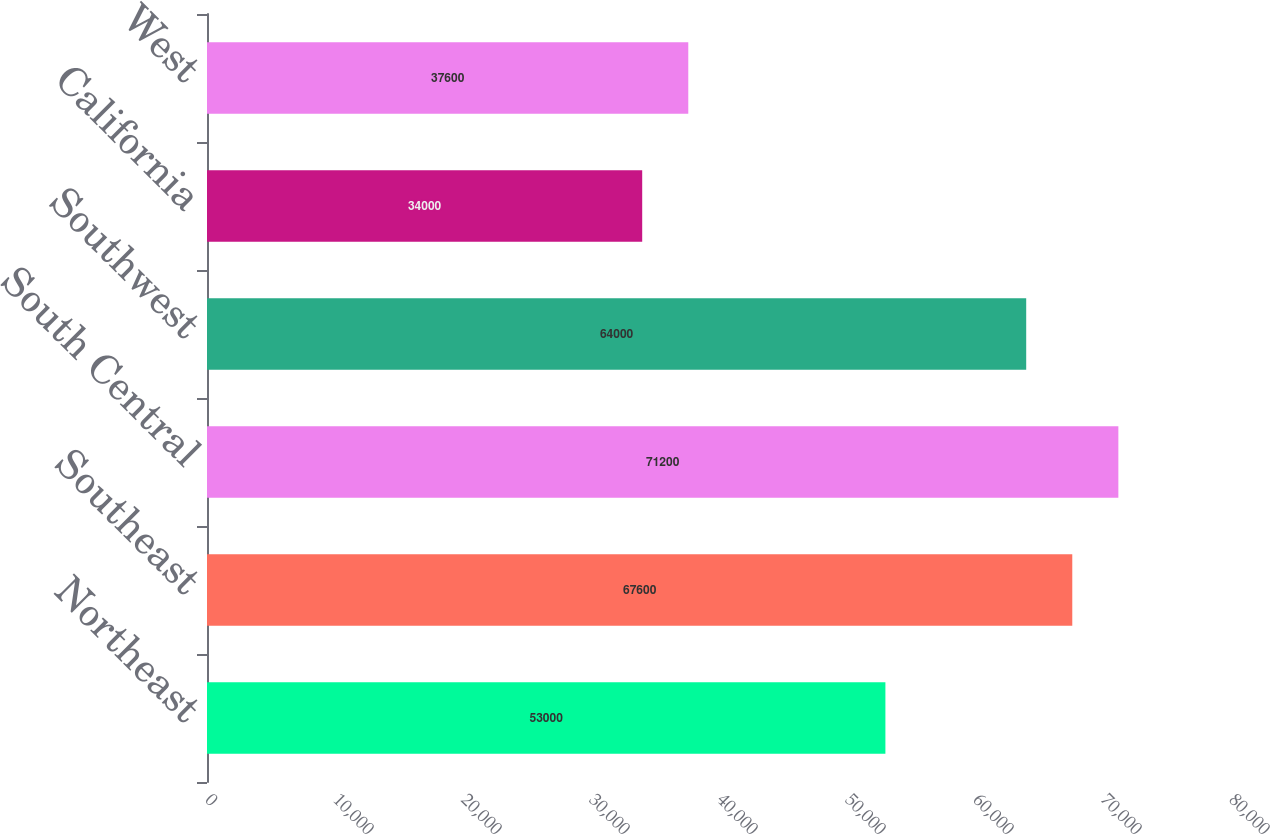Convert chart to OTSL. <chart><loc_0><loc_0><loc_500><loc_500><bar_chart><fcel>Northeast<fcel>Southeast<fcel>South Central<fcel>Southwest<fcel>California<fcel>West<nl><fcel>53000<fcel>67600<fcel>71200<fcel>64000<fcel>34000<fcel>37600<nl></chart> 